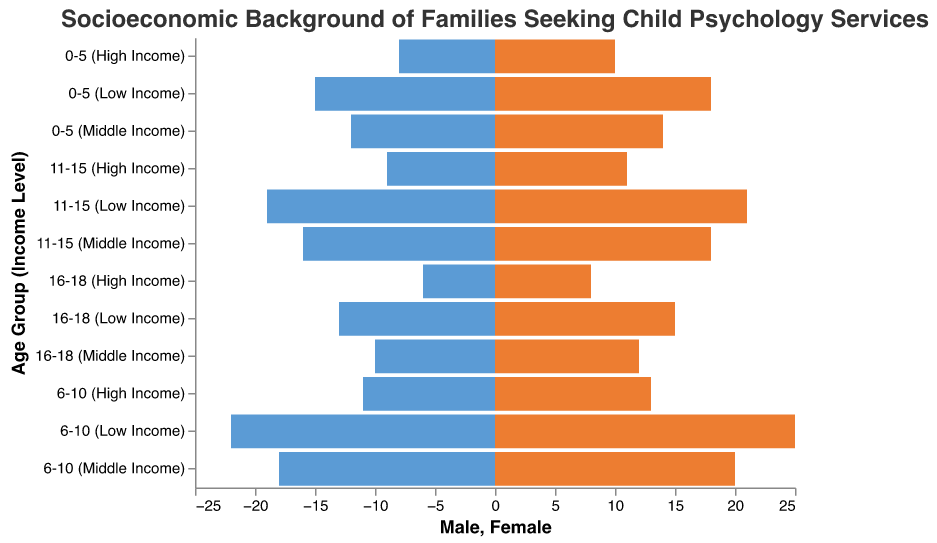What is the total number of male children aged 0-5 across all income levels? Adding the number of male children aged 0-5 in low, middle, and high-income levels: 15 (Low Income) + 12 (Middle Income) + 8 (High Income) = 35
Answer: 35 Which age group has the highest number of females in the low-income category? The number of female children in low-income category across age groups: 0-5 (18), 6-10 (25), 11-15 (21), 16-18 (15). Age group 6-10 has the highest number with 25 females.
Answer: 6-10 Are there more males or females in the middle-income group aged 6-10? Comparing the number of males and females in the middle-income group aged 6-10: 18 males and 20 females. There are more females.
Answer: Females How many children are there in the high-income category for the age group 11-15? Adding males and females in the high-income category for age group 11-15: 9 males + 11 females = 20 children.
Answer: 20 Which gender has the higher number in the lowest age group across all income levels? In the age group 0-5, adding males and females across low, middle, and high income: Males = 15 (Low) + 12 (Middle) + 8 (High) = 35; Females = 18 (Low) + 14 (Middle) + 10 (High) = 42. Females have a higher number.
Answer: Females Compare the number of children aged 16-18 in the middle-income category to that in the high-income category. For age group 16-18, middle-income: 10 males + 12 females = 22; high-income: 6 males + 8 females = 14. Middle-income category has more children.
Answer: Middle-income What is the average number of female children aged 6-10 across all income levels? Adding the number of female children aged 6-10 in low, middle, and high-income levels and dividing by 3: (25 + 20 + 13) / 3 = 58 / 3 = 19.33
Answer: 19.33 In the low-income category, which age group has the lowest number of males? Comparing the number of males in low-income across age groups: 0-5 (15), 6-10 (22), 11-15 (19), 16-18 (13). Age group 16-18 has the lowest number with 13 males.
Answer: 16-18 